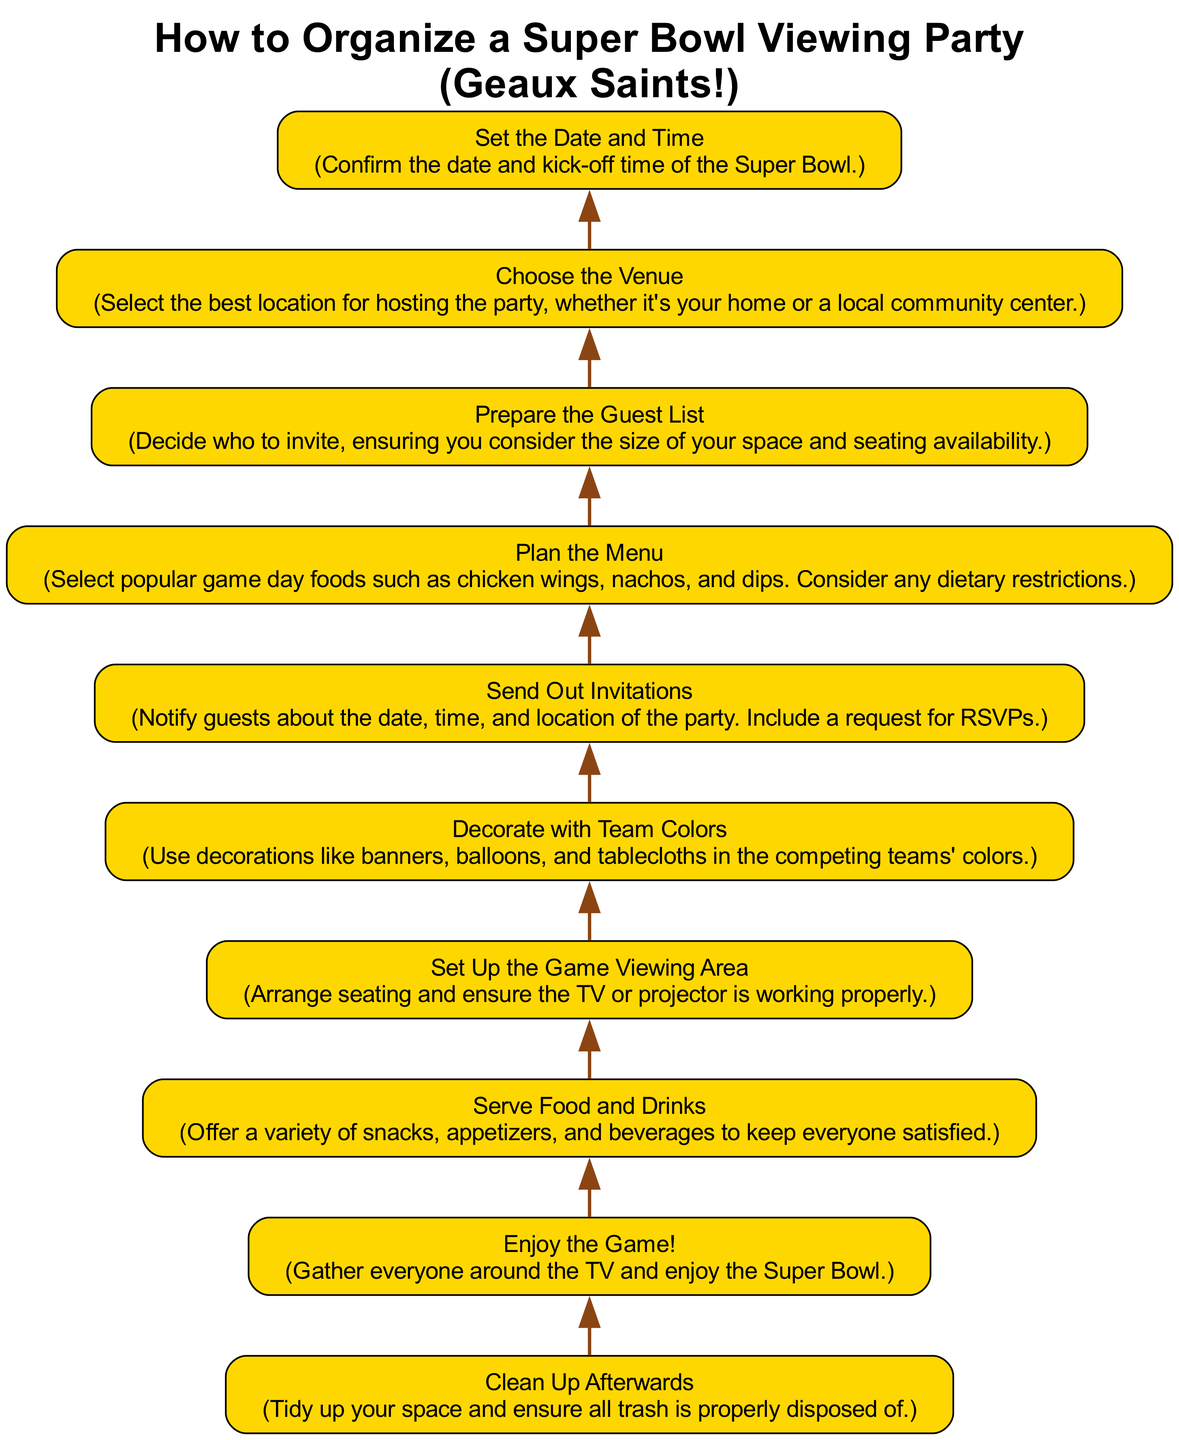What is the final step listed in the diagram? The final step in the flow chart is at the top, and it is "Enjoy the Game!" This indicates that after all preparations, the ultimate goal is to relax and have fun watching the Super Bowl.
Answer: Enjoy the Game! How many steps are there in total? By counting the nodes in the diagram, there are 10 distinct steps illustrating the process of organizing the viewing party.
Answer: 10 Which step comes before "Serve Food and Drinks"? By analyzing the flow from bottom to top, the step that directly precedes "Serve Food and Drinks" is "Set Up the Game Viewing Area." This indicates that food service follows the arrangement of the viewing area.
Answer: Set Up the Game Viewing Area At which point should invitations be sent out? The step "Send Out Invitations" appears towards the beginning of the flow chart, specifically after "Prepare the Guest List" and before "Plan the Menu," suggesting invitations should be sent after deciding who to invite.
Answer: After Prepare the Guest List What is the first step in the process? The first step in the process, located at the bottom of the flow chart, is "Choose the Venue." This indicates that selecting the location is foundational to organizing the party.
Answer: Choose the Venue Which steps are associated with food preparation? The steps that relate to food preparation in the context of the diagram are "Plan the Menu," and "Serve Food and Drinks." This grouping highlights that planning and serving food are crucial aspects of hosting the viewing party.
Answer: Plan the Menu, Serve Food and Drinks What is the relationship between "Decorate with Team Colors" and "Enjoy the Game!"? "Decorate with Team Colors" is positioned above "Enjoy the Game!" in the flow chart, indicating that decoration is a preceding step that enhances the viewing experience, culminating in the enjoyment of the game itself.
Answer: Decoration enhances enjoyment Which two steps are connected by an edge right after "Set the Date and Time"? The diagram indicates that the step "Choose the Venue" follows "Set the Date and Time," connected by an edge. This reflects the sequence that after confirming the date, the next action is to select a venue.
Answer: Choose the Venue Which step must be completed before "Clean Up Afterwards"? To determine the step that comes before "Clean Up Afterwards," we look to the flow chart and see that it follows "Enjoy the Game!," indicating that post-game clean-up occurs after the game is watched.
Answer: Enjoy the Game! 